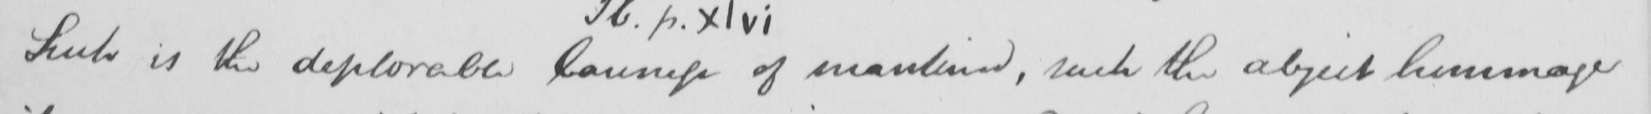Please transcribe the handwritten text in this image. Such is the deplorable laxness of mankind , such the abject hommage 